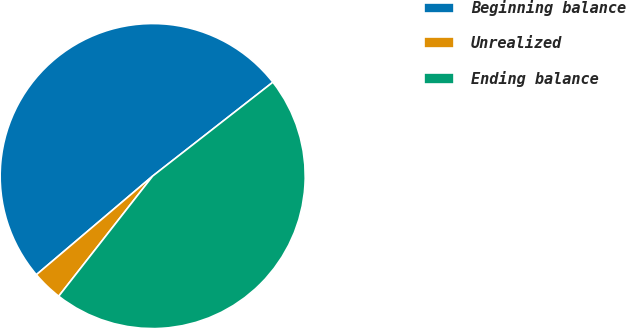<chart> <loc_0><loc_0><loc_500><loc_500><pie_chart><fcel>Beginning balance<fcel>Unrealized<fcel>Ending balance<nl><fcel>50.65%<fcel>3.24%<fcel>46.12%<nl></chart> 